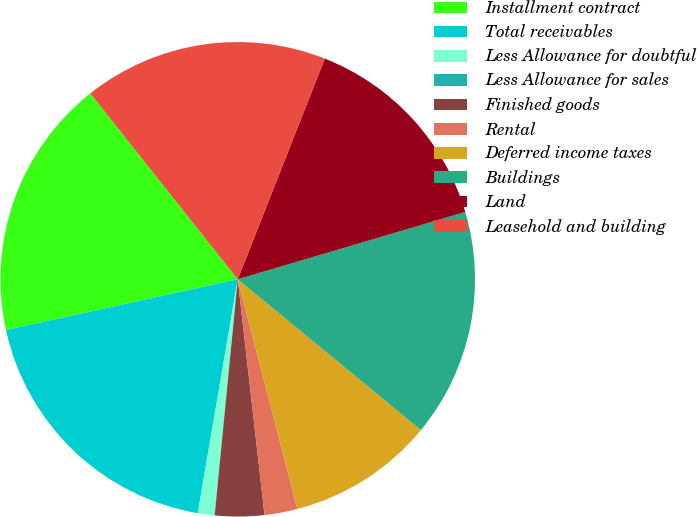<chart> <loc_0><loc_0><loc_500><loc_500><pie_chart><fcel>Installment contract<fcel>Total receivables<fcel>Less Allowance for doubtful<fcel>Less Allowance for sales<fcel>Finished goods<fcel>Rental<fcel>Deferred income taxes<fcel>Buildings<fcel>Land<fcel>Leasehold and building<nl><fcel>17.76%<fcel>18.87%<fcel>1.13%<fcel>0.02%<fcel>3.35%<fcel>2.24%<fcel>10.0%<fcel>15.54%<fcel>14.44%<fcel>16.65%<nl></chart> 